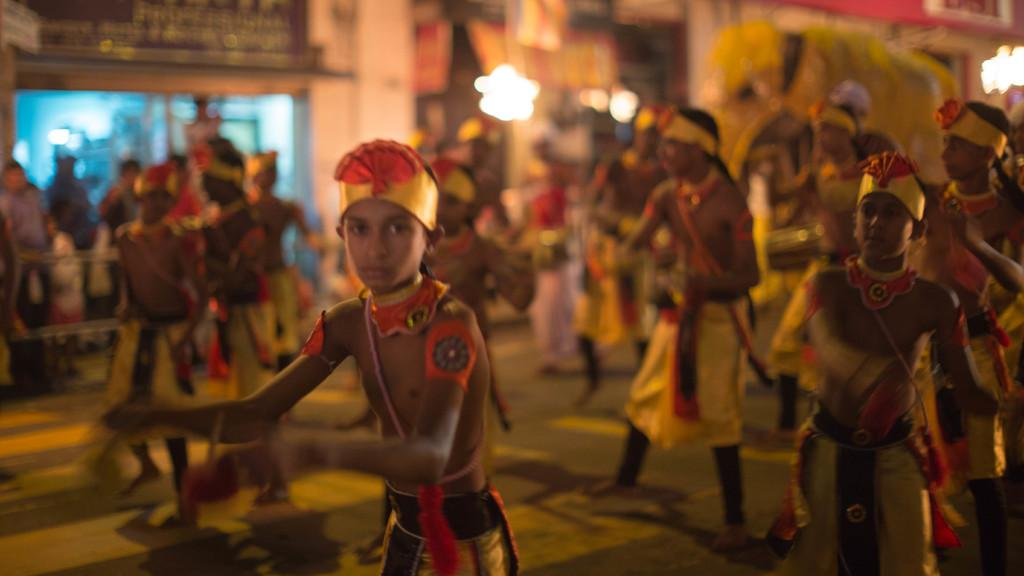What is the main subject of the image? The main subject of the image is a group of people. Where are the people located in the image? The people are on the floor. What can be seen in the background of the image? There are lights and blurry objects visible in the background of the image. How many babies are crawling on the floor in the image? There is no mention of babies in the image; it features a group of people on the floor. 